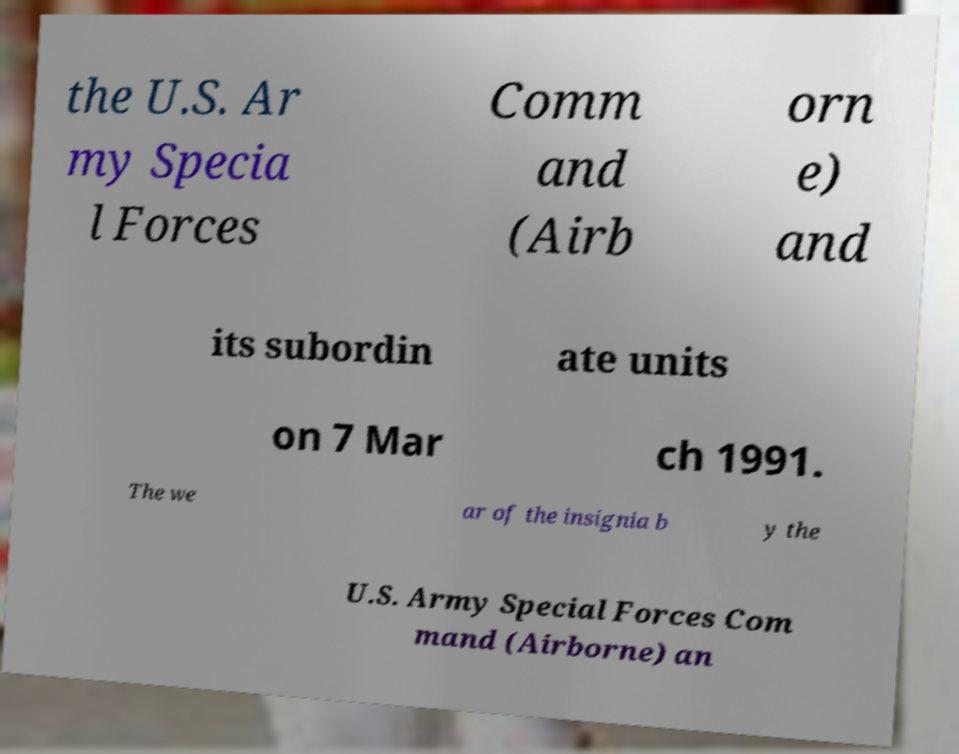There's text embedded in this image that I need extracted. Can you transcribe it verbatim? the U.S. Ar my Specia l Forces Comm and (Airb orn e) and its subordin ate units on 7 Mar ch 1991. The we ar of the insignia b y the U.S. Army Special Forces Com mand (Airborne) an 